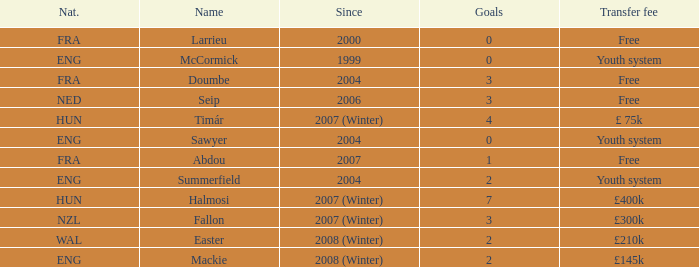What is the since year for the player with more than 3 goals and a transfer fee of £400k? 2007 (Winter). 